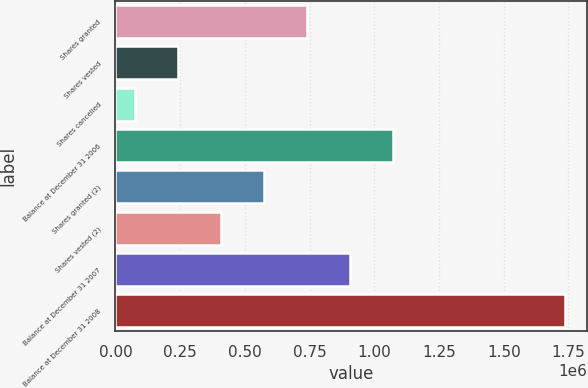<chart> <loc_0><loc_0><loc_500><loc_500><bar_chart><fcel>Shares granted<fcel>Shares vested<fcel>Shares cancelled<fcel>Balance at December 31 2006<fcel>Shares granted (2)<fcel>Shares vested (2)<fcel>Balance at December 31 2007<fcel>Balance at December 31 2008<nl><fcel>740139<fcel>241858<fcel>75765<fcel>1.07233e+06<fcel>574046<fcel>407952<fcel>906232<fcel>1.7367e+06<nl></chart> 